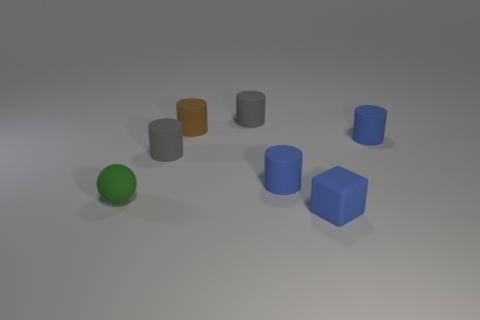Subtract all small gray cylinders. How many cylinders are left? 3 Subtract all brown cylinders. How many cylinders are left? 4 Subtract all red cylinders. Subtract all cyan balls. How many cylinders are left? 5 Add 2 blue rubber cylinders. How many objects exist? 9 Subtract all blocks. How many objects are left? 6 Subtract 0 red cubes. How many objects are left? 7 Subtract all tiny green objects. Subtract all blue rubber objects. How many objects are left? 3 Add 6 small gray cylinders. How many small gray cylinders are left? 8 Add 5 large yellow metallic things. How many large yellow metallic things exist? 5 